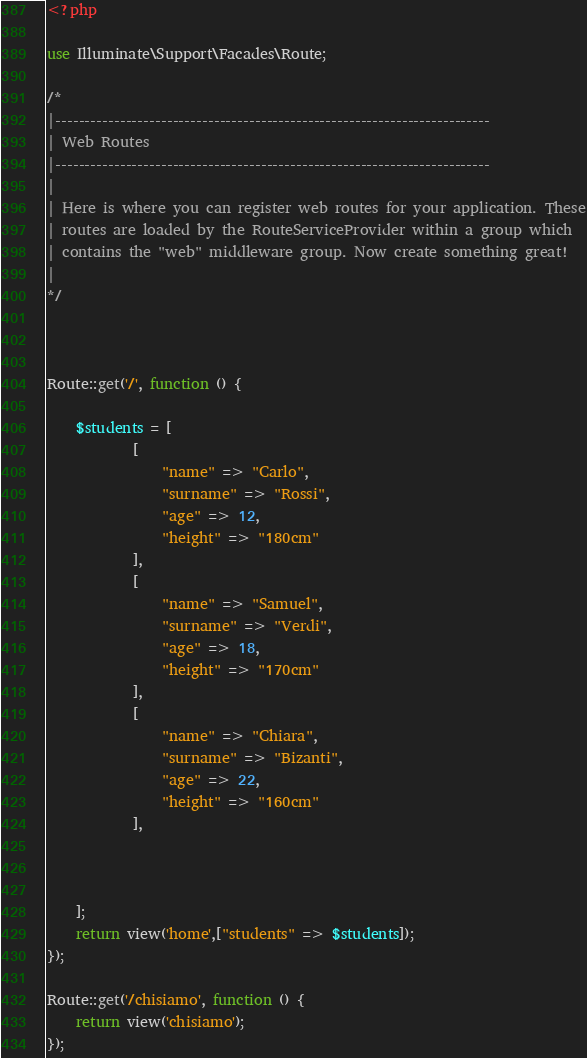<code> <loc_0><loc_0><loc_500><loc_500><_PHP_><?php

use Illuminate\Support\Facades\Route;

/*
|--------------------------------------------------------------------------
| Web Routes
|--------------------------------------------------------------------------
|
| Here is where you can register web routes for your application. These
| routes are loaded by the RouteServiceProvider within a group which
| contains the "web" middleware group. Now create something great!
|
*/



Route::get('/', function () {

    $students = [
            [
                "name" => "Carlo",
                "surname" => "Rossi",
                "age" => 12,
                "height" => "180cm"
            ],
            [
                "name" => "Samuel",
                "surname" => "Verdi",
                "age" => 18,
                "height" => "170cm"
            ],
            [
                "name" => "Chiara",
                "surname" => "Bizanti",
                "age" => 22,
                "height" => "160cm"
            ],
        
     
        
    ];
    return view('home',["students" => $students]);
});

Route::get('/chisiamo', function () {
    return view('chisiamo');
});
</code> 